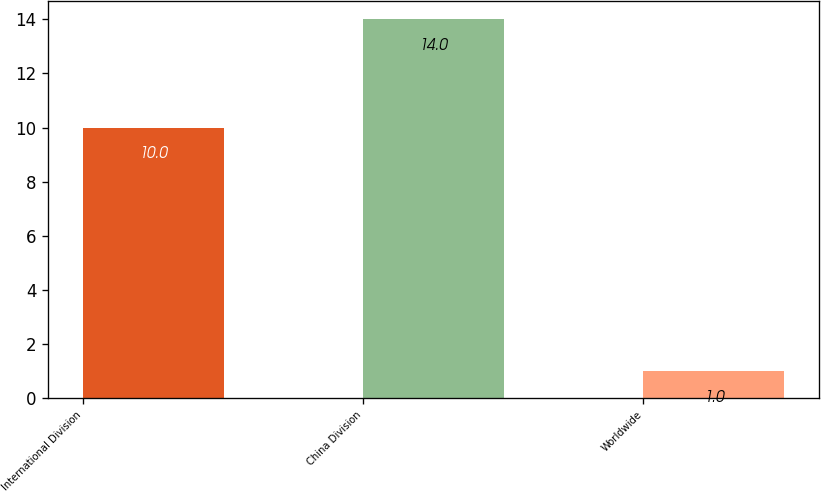<chart> <loc_0><loc_0><loc_500><loc_500><bar_chart><fcel>International Division<fcel>China Division<fcel>Worldwide<nl><fcel>10<fcel>14<fcel>1<nl></chart> 